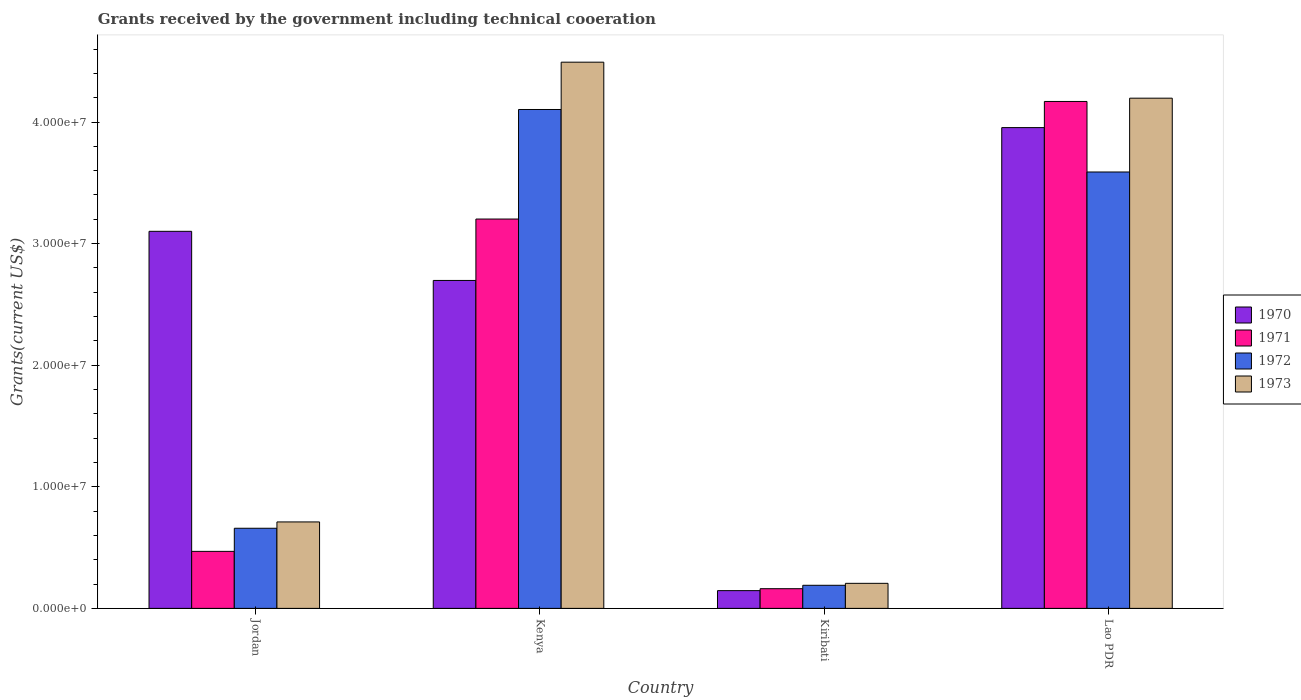Are the number of bars per tick equal to the number of legend labels?
Give a very brief answer. Yes. Are the number of bars on each tick of the X-axis equal?
Your response must be concise. Yes. What is the label of the 4th group of bars from the left?
Your answer should be compact. Lao PDR. What is the total grants received by the government in 1972 in Jordan?
Offer a very short reply. 6.59e+06. Across all countries, what is the maximum total grants received by the government in 1971?
Keep it short and to the point. 4.17e+07. Across all countries, what is the minimum total grants received by the government in 1973?
Provide a succinct answer. 2.06e+06. In which country was the total grants received by the government in 1972 maximum?
Your response must be concise. Kenya. In which country was the total grants received by the government in 1971 minimum?
Your answer should be compact. Kiribati. What is the total total grants received by the government in 1970 in the graph?
Keep it short and to the point. 9.90e+07. What is the difference between the total grants received by the government in 1973 in Kenya and that in Kiribati?
Ensure brevity in your answer.  4.29e+07. What is the difference between the total grants received by the government in 1972 in Kenya and the total grants received by the government in 1971 in Kiribati?
Your answer should be very brief. 3.94e+07. What is the average total grants received by the government in 1971 per country?
Your answer should be very brief. 2.00e+07. What is the difference between the total grants received by the government of/in 1973 and total grants received by the government of/in 1971 in Jordan?
Make the answer very short. 2.42e+06. In how many countries, is the total grants received by the government in 1972 greater than 12000000 US$?
Offer a very short reply. 2. What is the ratio of the total grants received by the government in 1971 in Jordan to that in Kiribati?
Give a very brief answer. 2.9. Is the difference between the total grants received by the government in 1973 in Jordan and Kiribati greater than the difference between the total grants received by the government in 1971 in Jordan and Kiribati?
Your answer should be compact. Yes. What is the difference between the highest and the second highest total grants received by the government in 1972?
Make the answer very short. 3.44e+07. What is the difference between the highest and the lowest total grants received by the government in 1972?
Your answer should be compact. 3.91e+07. Is the sum of the total grants received by the government in 1970 in Jordan and Kenya greater than the maximum total grants received by the government in 1973 across all countries?
Your response must be concise. Yes. Is it the case that in every country, the sum of the total grants received by the government in 1972 and total grants received by the government in 1970 is greater than the sum of total grants received by the government in 1973 and total grants received by the government in 1971?
Provide a succinct answer. No. How many bars are there?
Keep it short and to the point. 16. Are all the bars in the graph horizontal?
Ensure brevity in your answer.  No. Does the graph contain any zero values?
Give a very brief answer. No. Where does the legend appear in the graph?
Make the answer very short. Center right. How many legend labels are there?
Your response must be concise. 4. How are the legend labels stacked?
Your answer should be compact. Vertical. What is the title of the graph?
Provide a succinct answer. Grants received by the government including technical cooeration. Does "1974" appear as one of the legend labels in the graph?
Your answer should be compact. No. What is the label or title of the Y-axis?
Ensure brevity in your answer.  Grants(current US$). What is the Grants(current US$) in 1970 in Jordan?
Give a very brief answer. 3.10e+07. What is the Grants(current US$) of 1971 in Jordan?
Provide a short and direct response. 4.69e+06. What is the Grants(current US$) in 1972 in Jordan?
Make the answer very short. 6.59e+06. What is the Grants(current US$) in 1973 in Jordan?
Make the answer very short. 7.11e+06. What is the Grants(current US$) in 1970 in Kenya?
Make the answer very short. 2.70e+07. What is the Grants(current US$) in 1971 in Kenya?
Provide a succinct answer. 3.20e+07. What is the Grants(current US$) in 1972 in Kenya?
Your answer should be very brief. 4.10e+07. What is the Grants(current US$) of 1973 in Kenya?
Make the answer very short. 4.49e+07. What is the Grants(current US$) in 1970 in Kiribati?
Offer a very short reply. 1.46e+06. What is the Grants(current US$) in 1971 in Kiribati?
Offer a very short reply. 1.62e+06. What is the Grants(current US$) in 1972 in Kiribati?
Give a very brief answer. 1.90e+06. What is the Grants(current US$) in 1973 in Kiribati?
Offer a terse response. 2.06e+06. What is the Grants(current US$) in 1970 in Lao PDR?
Your response must be concise. 3.95e+07. What is the Grants(current US$) in 1971 in Lao PDR?
Your answer should be very brief. 4.17e+07. What is the Grants(current US$) of 1972 in Lao PDR?
Offer a very short reply. 3.59e+07. What is the Grants(current US$) of 1973 in Lao PDR?
Offer a terse response. 4.20e+07. Across all countries, what is the maximum Grants(current US$) in 1970?
Provide a short and direct response. 3.95e+07. Across all countries, what is the maximum Grants(current US$) of 1971?
Keep it short and to the point. 4.17e+07. Across all countries, what is the maximum Grants(current US$) in 1972?
Offer a terse response. 4.10e+07. Across all countries, what is the maximum Grants(current US$) of 1973?
Offer a very short reply. 4.49e+07. Across all countries, what is the minimum Grants(current US$) of 1970?
Give a very brief answer. 1.46e+06. Across all countries, what is the minimum Grants(current US$) of 1971?
Ensure brevity in your answer.  1.62e+06. Across all countries, what is the minimum Grants(current US$) of 1972?
Your answer should be very brief. 1.90e+06. Across all countries, what is the minimum Grants(current US$) of 1973?
Your answer should be compact. 2.06e+06. What is the total Grants(current US$) of 1970 in the graph?
Offer a very short reply. 9.90e+07. What is the total Grants(current US$) of 1971 in the graph?
Offer a very short reply. 8.00e+07. What is the total Grants(current US$) of 1972 in the graph?
Provide a short and direct response. 8.54e+07. What is the total Grants(current US$) in 1973 in the graph?
Offer a terse response. 9.60e+07. What is the difference between the Grants(current US$) in 1970 in Jordan and that in Kenya?
Your answer should be compact. 4.04e+06. What is the difference between the Grants(current US$) in 1971 in Jordan and that in Kenya?
Ensure brevity in your answer.  -2.73e+07. What is the difference between the Grants(current US$) of 1972 in Jordan and that in Kenya?
Offer a terse response. -3.44e+07. What is the difference between the Grants(current US$) in 1973 in Jordan and that in Kenya?
Make the answer very short. -3.78e+07. What is the difference between the Grants(current US$) in 1970 in Jordan and that in Kiribati?
Your answer should be very brief. 2.96e+07. What is the difference between the Grants(current US$) in 1971 in Jordan and that in Kiribati?
Provide a short and direct response. 3.07e+06. What is the difference between the Grants(current US$) of 1972 in Jordan and that in Kiribati?
Give a very brief answer. 4.69e+06. What is the difference between the Grants(current US$) in 1973 in Jordan and that in Kiribati?
Give a very brief answer. 5.05e+06. What is the difference between the Grants(current US$) in 1970 in Jordan and that in Lao PDR?
Keep it short and to the point. -8.53e+06. What is the difference between the Grants(current US$) in 1971 in Jordan and that in Lao PDR?
Ensure brevity in your answer.  -3.70e+07. What is the difference between the Grants(current US$) of 1972 in Jordan and that in Lao PDR?
Provide a short and direct response. -2.93e+07. What is the difference between the Grants(current US$) in 1973 in Jordan and that in Lao PDR?
Ensure brevity in your answer.  -3.48e+07. What is the difference between the Grants(current US$) in 1970 in Kenya and that in Kiribati?
Your response must be concise. 2.55e+07. What is the difference between the Grants(current US$) of 1971 in Kenya and that in Kiribati?
Your answer should be very brief. 3.04e+07. What is the difference between the Grants(current US$) of 1972 in Kenya and that in Kiribati?
Offer a very short reply. 3.91e+07. What is the difference between the Grants(current US$) in 1973 in Kenya and that in Kiribati?
Ensure brevity in your answer.  4.29e+07. What is the difference between the Grants(current US$) of 1970 in Kenya and that in Lao PDR?
Offer a terse response. -1.26e+07. What is the difference between the Grants(current US$) in 1971 in Kenya and that in Lao PDR?
Ensure brevity in your answer.  -9.67e+06. What is the difference between the Grants(current US$) of 1972 in Kenya and that in Lao PDR?
Provide a short and direct response. 5.14e+06. What is the difference between the Grants(current US$) in 1973 in Kenya and that in Lao PDR?
Keep it short and to the point. 2.96e+06. What is the difference between the Grants(current US$) in 1970 in Kiribati and that in Lao PDR?
Offer a very short reply. -3.81e+07. What is the difference between the Grants(current US$) of 1971 in Kiribati and that in Lao PDR?
Ensure brevity in your answer.  -4.01e+07. What is the difference between the Grants(current US$) of 1972 in Kiribati and that in Lao PDR?
Ensure brevity in your answer.  -3.40e+07. What is the difference between the Grants(current US$) in 1973 in Kiribati and that in Lao PDR?
Provide a succinct answer. -3.99e+07. What is the difference between the Grants(current US$) in 1970 in Jordan and the Grants(current US$) in 1971 in Kenya?
Provide a succinct answer. -1.01e+06. What is the difference between the Grants(current US$) in 1970 in Jordan and the Grants(current US$) in 1972 in Kenya?
Ensure brevity in your answer.  -1.00e+07. What is the difference between the Grants(current US$) in 1970 in Jordan and the Grants(current US$) in 1973 in Kenya?
Give a very brief answer. -1.39e+07. What is the difference between the Grants(current US$) of 1971 in Jordan and the Grants(current US$) of 1972 in Kenya?
Provide a short and direct response. -3.63e+07. What is the difference between the Grants(current US$) in 1971 in Jordan and the Grants(current US$) in 1973 in Kenya?
Give a very brief answer. -4.02e+07. What is the difference between the Grants(current US$) of 1972 in Jordan and the Grants(current US$) of 1973 in Kenya?
Make the answer very short. -3.83e+07. What is the difference between the Grants(current US$) in 1970 in Jordan and the Grants(current US$) in 1971 in Kiribati?
Provide a succinct answer. 2.94e+07. What is the difference between the Grants(current US$) of 1970 in Jordan and the Grants(current US$) of 1972 in Kiribati?
Ensure brevity in your answer.  2.91e+07. What is the difference between the Grants(current US$) of 1970 in Jordan and the Grants(current US$) of 1973 in Kiribati?
Give a very brief answer. 2.90e+07. What is the difference between the Grants(current US$) of 1971 in Jordan and the Grants(current US$) of 1972 in Kiribati?
Your answer should be compact. 2.79e+06. What is the difference between the Grants(current US$) of 1971 in Jordan and the Grants(current US$) of 1973 in Kiribati?
Offer a very short reply. 2.63e+06. What is the difference between the Grants(current US$) of 1972 in Jordan and the Grants(current US$) of 1973 in Kiribati?
Your response must be concise. 4.53e+06. What is the difference between the Grants(current US$) in 1970 in Jordan and the Grants(current US$) in 1971 in Lao PDR?
Your response must be concise. -1.07e+07. What is the difference between the Grants(current US$) of 1970 in Jordan and the Grants(current US$) of 1972 in Lao PDR?
Give a very brief answer. -4.88e+06. What is the difference between the Grants(current US$) of 1970 in Jordan and the Grants(current US$) of 1973 in Lao PDR?
Make the answer very short. -1.10e+07. What is the difference between the Grants(current US$) in 1971 in Jordan and the Grants(current US$) in 1972 in Lao PDR?
Your answer should be compact. -3.12e+07. What is the difference between the Grants(current US$) of 1971 in Jordan and the Grants(current US$) of 1973 in Lao PDR?
Your answer should be compact. -3.73e+07. What is the difference between the Grants(current US$) in 1972 in Jordan and the Grants(current US$) in 1973 in Lao PDR?
Your answer should be very brief. -3.54e+07. What is the difference between the Grants(current US$) of 1970 in Kenya and the Grants(current US$) of 1971 in Kiribati?
Your answer should be compact. 2.54e+07. What is the difference between the Grants(current US$) in 1970 in Kenya and the Grants(current US$) in 1972 in Kiribati?
Provide a succinct answer. 2.51e+07. What is the difference between the Grants(current US$) of 1970 in Kenya and the Grants(current US$) of 1973 in Kiribati?
Provide a short and direct response. 2.49e+07. What is the difference between the Grants(current US$) of 1971 in Kenya and the Grants(current US$) of 1972 in Kiribati?
Keep it short and to the point. 3.01e+07. What is the difference between the Grants(current US$) in 1971 in Kenya and the Grants(current US$) in 1973 in Kiribati?
Provide a succinct answer. 3.00e+07. What is the difference between the Grants(current US$) of 1972 in Kenya and the Grants(current US$) of 1973 in Kiribati?
Keep it short and to the point. 3.90e+07. What is the difference between the Grants(current US$) in 1970 in Kenya and the Grants(current US$) in 1971 in Lao PDR?
Offer a very short reply. -1.47e+07. What is the difference between the Grants(current US$) in 1970 in Kenya and the Grants(current US$) in 1972 in Lao PDR?
Your answer should be compact. -8.92e+06. What is the difference between the Grants(current US$) in 1970 in Kenya and the Grants(current US$) in 1973 in Lao PDR?
Ensure brevity in your answer.  -1.50e+07. What is the difference between the Grants(current US$) of 1971 in Kenya and the Grants(current US$) of 1972 in Lao PDR?
Give a very brief answer. -3.87e+06. What is the difference between the Grants(current US$) of 1971 in Kenya and the Grants(current US$) of 1973 in Lao PDR?
Offer a terse response. -9.94e+06. What is the difference between the Grants(current US$) in 1972 in Kenya and the Grants(current US$) in 1973 in Lao PDR?
Offer a very short reply. -9.30e+05. What is the difference between the Grants(current US$) of 1970 in Kiribati and the Grants(current US$) of 1971 in Lao PDR?
Provide a succinct answer. -4.02e+07. What is the difference between the Grants(current US$) in 1970 in Kiribati and the Grants(current US$) in 1972 in Lao PDR?
Provide a short and direct response. -3.44e+07. What is the difference between the Grants(current US$) of 1970 in Kiribati and the Grants(current US$) of 1973 in Lao PDR?
Your response must be concise. -4.05e+07. What is the difference between the Grants(current US$) of 1971 in Kiribati and the Grants(current US$) of 1972 in Lao PDR?
Make the answer very short. -3.43e+07. What is the difference between the Grants(current US$) in 1971 in Kiribati and the Grants(current US$) in 1973 in Lao PDR?
Provide a short and direct response. -4.03e+07. What is the difference between the Grants(current US$) of 1972 in Kiribati and the Grants(current US$) of 1973 in Lao PDR?
Provide a short and direct response. -4.01e+07. What is the average Grants(current US$) of 1970 per country?
Your answer should be very brief. 2.47e+07. What is the average Grants(current US$) of 1971 per country?
Offer a terse response. 2.00e+07. What is the average Grants(current US$) of 1972 per country?
Offer a terse response. 2.14e+07. What is the average Grants(current US$) in 1973 per country?
Offer a very short reply. 2.40e+07. What is the difference between the Grants(current US$) of 1970 and Grants(current US$) of 1971 in Jordan?
Ensure brevity in your answer.  2.63e+07. What is the difference between the Grants(current US$) in 1970 and Grants(current US$) in 1972 in Jordan?
Ensure brevity in your answer.  2.44e+07. What is the difference between the Grants(current US$) of 1970 and Grants(current US$) of 1973 in Jordan?
Provide a short and direct response. 2.39e+07. What is the difference between the Grants(current US$) in 1971 and Grants(current US$) in 1972 in Jordan?
Offer a terse response. -1.90e+06. What is the difference between the Grants(current US$) of 1971 and Grants(current US$) of 1973 in Jordan?
Offer a very short reply. -2.42e+06. What is the difference between the Grants(current US$) of 1972 and Grants(current US$) of 1973 in Jordan?
Make the answer very short. -5.20e+05. What is the difference between the Grants(current US$) of 1970 and Grants(current US$) of 1971 in Kenya?
Your response must be concise. -5.05e+06. What is the difference between the Grants(current US$) in 1970 and Grants(current US$) in 1972 in Kenya?
Make the answer very short. -1.41e+07. What is the difference between the Grants(current US$) of 1970 and Grants(current US$) of 1973 in Kenya?
Ensure brevity in your answer.  -1.80e+07. What is the difference between the Grants(current US$) of 1971 and Grants(current US$) of 1972 in Kenya?
Your response must be concise. -9.01e+06. What is the difference between the Grants(current US$) of 1971 and Grants(current US$) of 1973 in Kenya?
Give a very brief answer. -1.29e+07. What is the difference between the Grants(current US$) in 1972 and Grants(current US$) in 1973 in Kenya?
Give a very brief answer. -3.89e+06. What is the difference between the Grants(current US$) in 1970 and Grants(current US$) in 1971 in Kiribati?
Your answer should be very brief. -1.60e+05. What is the difference between the Grants(current US$) of 1970 and Grants(current US$) of 1972 in Kiribati?
Keep it short and to the point. -4.40e+05. What is the difference between the Grants(current US$) in 1970 and Grants(current US$) in 1973 in Kiribati?
Make the answer very short. -6.00e+05. What is the difference between the Grants(current US$) of 1971 and Grants(current US$) of 1972 in Kiribati?
Ensure brevity in your answer.  -2.80e+05. What is the difference between the Grants(current US$) of 1971 and Grants(current US$) of 1973 in Kiribati?
Provide a succinct answer. -4.40e+05. What is the difference between the Grants(current US$) of 1970 and Grants(current US$) of 1971 in Lao PDR?
Offer a very short reply. -2.15e+06. What is the difference between the Grants(current US$) in 1970 and Grants(current US$) in 1972 in Lao PDR?
Your answer should be very brief. 3.65e+06. What is the difference between the Grants(current US$) of 1970 and Grants(current US$) of 1973 in Lao PDR?
Provide a short and direct response. -2.42e+06. What is the difference between the Grants(current US$) in 1971 and Grants(current US$) in 1972 in Lao PDR?
Provide a short and direct response. 5.80e+06. What is the difference between the Grants(current US$) in 1971 and Grants(current US$) in 1973 in Lao PDR?
Provide a short and direct response. -2.70e+05. What is the difference between the Grants(current US$) in 1972 and Grants(current US$) in 1973 in Lao PDR?
Offer a very short reply. -6.07e+06. What is the ratio of the Grants(current US$) of 1970 in Jordan to that in Kenya?
Your answer should be very brief. 1.15. What is the ratio of the Grants(current US$) of 1971 in Jordan to that in Kenya?
Your response must be concise. 0.15. What is the ratio of the Grants(current US$) in 1972 in Jordan to that in Kenya?
Provide a succinct answer. 0.16. What is the ratio of the Grants(current US$) of 1973 in Jordan to that in Kenya?
Your answer should be compact. 0.16. What is the ratio of the Grants(current US$) in 1970 in Jordan to that in Kiribati?
Provide a short and direct response. 21.24. What is the ratio of the Grants(current US$) in 1971 in Jordan to that in Kiribati?
Your answer should be compact. 2.9. What is the ratio of the Grants(current US$) of 1972 in Jordan to that in Kiribati?
Ensure brevity in your answer.  3.47. What is the ratio of the Grants(current US$) in 1973 in Jordan to that in Kiribati?
Give a very brief answer. 3.45. What is the ratio of the Grants(current US$) in 1970 in Jordan to that in Lao PDR?
Offer a very short reply. 0.78. What is the ratio of the Grants(current US$) in 1971 in Jordan to that in Lao PDR?
Ensure brevity in your answer.  0.11. What is the ratio of the Grants(current US$) in 1972 in Jordan to that in Lao PDR?
Make the answer very short. 0.18. What is the ratio of the Grants(current US$) of 1973 in Jordan to that in Lao PDR?
Provide a succinct answer. 0.17. What is the ratio of the Grants(current US$) in 1970 in Kenya to that in Kiribati?
Keep it short and to the point. 18.47. What is the ratio of the Grants(current US$) in 1971 in Kenya to that in Kiribati?
Your response must be concise. 19.77. What is the ratio of the Grants(current US$) in 1972 in Kenya to that in Kiribati?
Offer a terse response. 21.59. What is the ratio of the Grants(current US$) in 1973 in Kenya to that in Kiribati?
Make the answer very short. 21.81. What is the ratio of the Grants(current US$) in 1970 in Kenya to that in Lao PDR?
Provide a succinct answer. 0.68. What is the ratio of the Grants(current US$) in 1971 in Kenya to that in Lao PDR?
Your response must be concise. 0.77. What is the ratio of the Grants(current US$) in 1972 in Kenya to that in Lao PDR?
Give a very brief answer. 1.14. What is the ratio of the Grants(current US$) in 1973 in Kenya to that in Lao PDR?
Your answer should be compact. 1.07. What is the ratio of the Grants(current US$) in 1970 in Kiribati to that in Lao PDR?
Offer a terse response. 0.04. What is the ratio of the Grants(current US$) in 1971 in Kiribati to that in Lao PDR?
Provide a short and direct response. 0.04. What is the ratio of the Grants(current US$) in 1972 in Kiribati to that in Lao PDR?
Ensure brevity in your answer.  0.05. What is the ratio of the Grants(current US$) of 1973 in Kiribati to that in Lao PDR?
Provide a short and direct response. 0.05. What is the difference between the highest and the second highest Grants(current US$) of 1970?
Give a very brief answer. 8.53e+06. What is the difference between the highest and the second highest Grants(current US$) in 1971?
Your response must be concise. 9.67e+06. What is the difference between the highest and the second highest Grants(current US$) of 1972?
Provide a succinct answer. 5.14e+06. What is the difference between the highest and the second highest Grants(current US$) in 1973?
Your answer should be compact. 2.96e+06. What is the difference between the highest and the lowest Grants(current US$) in 1970?
Your answer should be very brief. 3.81e+07. What is the difference between the highest and the lowest Grants(current US$) in 1971?
Your answer should be very brief. 4.01e+07. What is the difference between the highest and the lowest Grants(current US$) in 1972?
Your answer should be very brief. 3.91e+07. What is the difference between the highest and the lowest Grants(current US$) of 1973?
Offer a very short reply. 4.29e+07. 